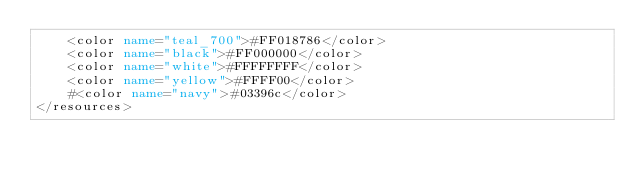Convert code to text. <code><loc_0><loc_0><loc_500><loc_500><_XML_>    <color name="teal_700">#FF018786</color>
    <color name="black">#FF000000</color>
    <color name="white">#FFFFFFFF</color>
    <color name="yellow">#FFFF00</color>
    #<color name="navy">#03396c</color>
</resources></code> 